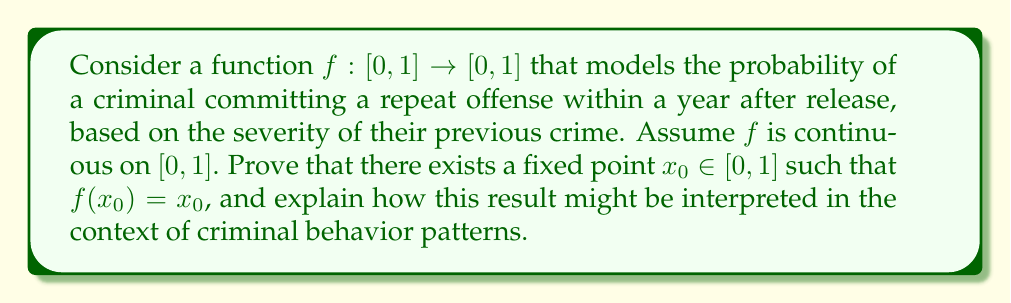Teach me how to tackle this problem. To prove the existence of a fixed point, we'll use the Intermediate Value Theorem (IVT). Here's a step-by-step approach:

1) Define the function $g(x) = f(x) - x$ for $x \in [0,1]$.

2) Since $f$ is continuous on $[0,1]$, $g$ is also continuous on $[0,1]$.

3) Consider the endpoints of the interval:
   At $x = 0$: $g(0) = f(0) - 0 = f(0) \geq 0$
   At $x = 1$: $g(1) = f(1) - 1 \leq 0$

4) By the IVT, since $g$ is continuous and changes sign from non-negative to non-positive over $[0,1]$, there must exist a point $x_0 \in [0,1]$ such that $g(x_0) = 0$.

5) At this point $x_0$, we have:
   $g(x_0) = 0$
   $f(x_0) - x_0 = 0$
   $f(x_0) = x_0$

Therefore, $x_0$ is a fixed point of $f$.

Interpretation: In the context of criminal behavior patterns, this fixed point represents a "stable" severity level where the probability of reoffending matches the severity of the previous crime. This could indicate a self-reinforcing cycle in criminal behavior, where the likelihood of committing another crime of similar severity remains constant.
Answer: The function $f$ has at least one fixed point $x_0 \in [0,1]$ such that $f(x_0) = x_0$, as proven by applying the Intermediate Value Theorem to the function $g(x) = f(x) - x$ on the interval $[0,1]$. 